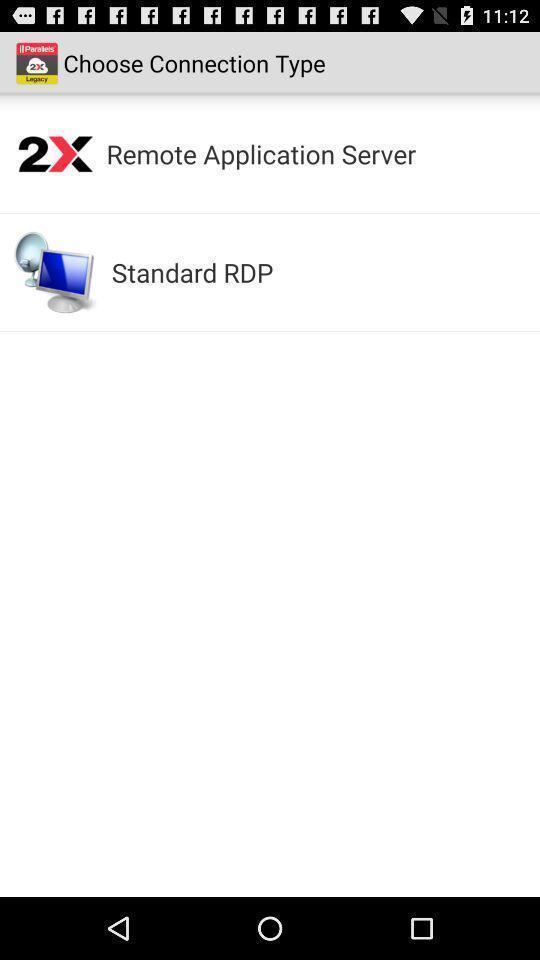Tell me what you see in this picture. Screen showing choose connection type. 